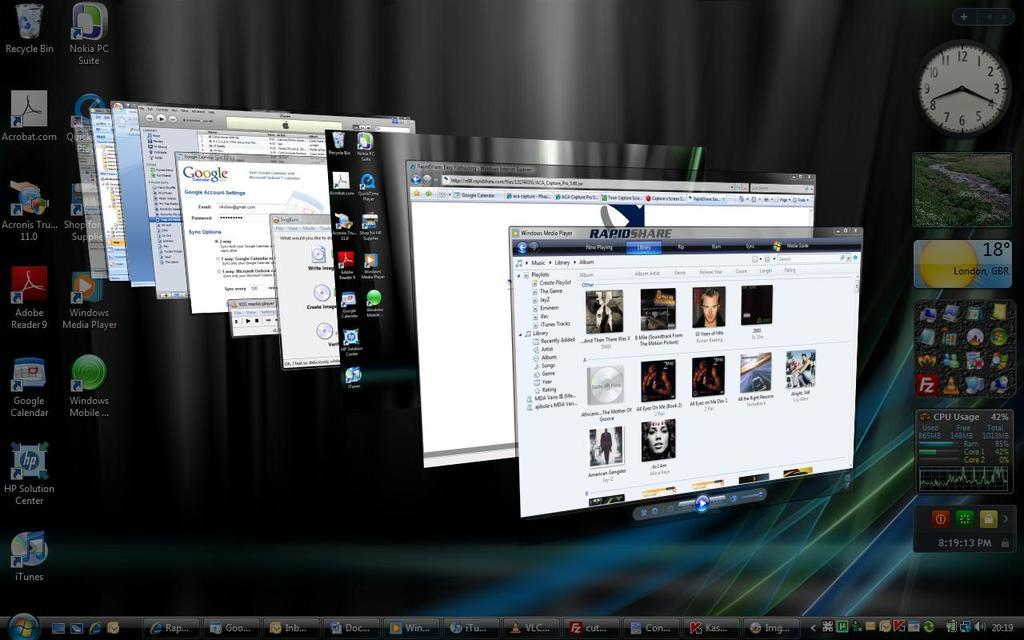What is the main subject of the image? The main subject of the image is a screenshot of a monitor. What can be seen on the monitor? There are tabs opened on the monitor, and applications are visible in the background. Where are the tabs located on the screen? There are tabs at the bottom of the screen. What additional information is displayed on the screen? The time and location are displayed on the screen. What type of flesh can be seen in the image? There is no flesh present in the image; it is a screenshot of a monitor displaying tabs and applications. 